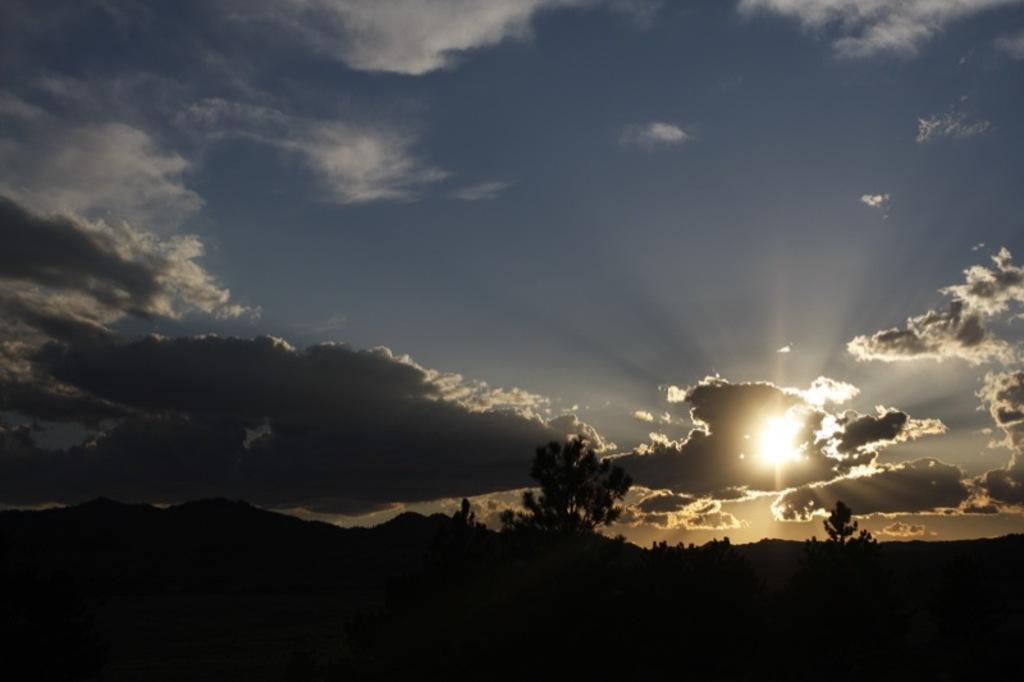Could you give a brief overview of what you see in this image? In this image we can see sky with clouds, hills and trees. 